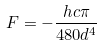<formula> <loc_0><loc_0><loc_500><loc_500>F = - \frac { h c \pi } { 4 8 0 d ^ { 4 } }</formula> 